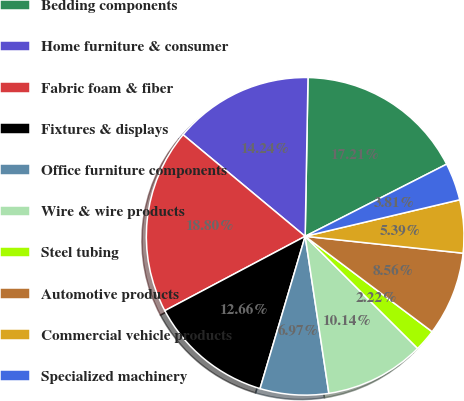<chart> <loc_0><loc_0><loc_500><loc_500><pie_chart><fcel>Bedding components<fcel>Home furniture & consumer<fcel>Fabric foam & fiber<fcel>Fixtures & displays<fcel>Office furniture components<fcel>Wire & wire products<fcel>Steel tubing<fcel>Automotive products<fcel>Commercial vehicle products<fcel>Specialized machinery<nl><fcel>17.21%<fcel>14.24%<fcel>18.8%<fcel>12.66%<fcel>6.97%<fcel>10.14%<fcel>2.22%<fcel>8.56%<fcel>5.39%<fcel>3.81%<nl></chart> 